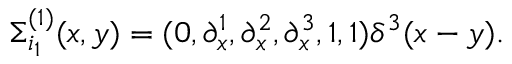<formula> <loc_0><loc_0><loc_500><loc_500>\Sigma _ { i _ { 1 } } ^ { ( 1 ) } ( x , y ) = ( 0 , \partial _ { x } ^ { 1 } , \partial _ { x } ^ { 2 } , \partial _ { x } ^ { 3 } , 1 , 1 ) \delta ^ { 3 } ( x - y ) .</formula> 